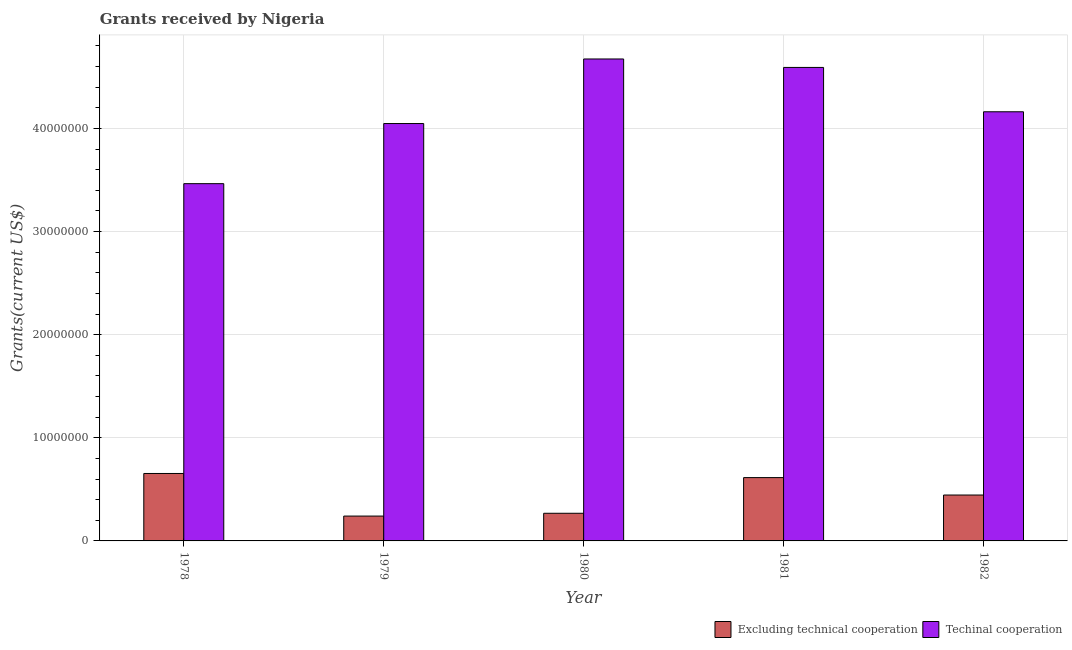Are the number of bars on each tick of the X-axis equal?
Offer a terse response. Yes. How many bars are there on the 3rd tick from the left?
Your answer should be compact. 2. How many bars are there on the 2nd tick from the right?
Your response must be concise. 2. What is the label of the 4th group of bars from the left?
Make the answer very short. 1981. In how many cases, is the number of bars for a given year not equal to the number of legend labels?
Your answer should be compact. 0. What is the amount of grants received(including technical cooperation) in 1978?
Make the answer very short. 3.46e+07. Across all years, what is the maximum amount of grants received(including technical cooperation)?
Make the answer very short. 4.67e+07. Across all years, what is the minimum amount of grants received(excluding technical cooperation)?
Give a very brief answer. 2.41e+06. In which year was the amount of grants received(excluding technical cooperation) maximum?
Provide a succinct answer. 1978. In which year was the amount of grants received(including technical cooperation) minimum?
Make the answer very short. 1978. What is the total amount of grants received(excluding technical cooperation) in the graph?
Provide a succinct answer. 2.22e+07. What is the difference between the amount of grants received(excluding technical cooperation) in 1981 and that in 1982?
Your answer should be compact. 1.69e+06. What is the difference between the amount of grants received(excluding technical cooperation) in 1978 and the amount of grants received(including technical cooperation) in 1981?
Offer a terse response. 4.00e+05. What is the average amount of grants received(excluding technical cooperation) per year?
Offer a very short reply. 4.44e+06. In the year 1981, what is the difference between the amount of grants received(including technical cooperation) and amount of grants received(excluding technical cooperation)?
Your answer should be compact. 0. What is the ratio of the amount of grants received(including technical cooperation) in 1978 to that in 1979?
Your answer should be very brief. 0.86. Is the amount of grants received(including technical cooperation) in 1980 less than that in 1982?
Give a very brief answer. No. Is the difference between the amount of grants received(excluding technical cooperation) in 1978 and 1981 greater than the difference between the amount of grants received(including technical cooperation) in 1978 and 1981?
Offer a very short reply. No. What is the difference between the highest and the second highest amount of grants received(including technical cooperation)?
Offer a very short reply. 8.20e+05. What is the difference between the highest and the lowest amount of grants received(including technical cooperation)?
Offer a very short reply. 1.21e+07. What does the 2nd bar from the left in 1978 represents?
Your answer should be compact. Techinal cooperation. What does the 2nd bar from the right in 1982 represents?
Your answer should be very brief. Excluding technical cooperation. How many years are there in the graph?
Your response must be concise. 5. What is the difference between two consecutive major ticks on the Y-axis?
Provide a short and direct response. 1.00e+07. Does the graph contain any zero values?
Make the answer very short. No. Does the graph contain grids?
Your answer should be very brief. Yes. What is the title of the graph?
Provide a succinct answer. Grants received by Nigeria. Does "Quality of trade" appear as one of the legend labels in the graph?
Offer a terse response. No. What is the label or title of the X-axis?
Keep it short and to the point. Year. What is the label or title of the Y-axis?
Keep it short and to the point. Grants(current US$). What is the Grants(current US$) in Excluding technical cooperation in 1978?
Your response must be concise. 6.54e+06. What is the Grants(current US$) of Techinal cooperation in 1978?
Offer a terse response. 3.46e+07. What is the Grants(current US$) in Excluding technical cooperation in 1979?
Provide a short and direct response. 2.41e+06. What is the Grants(current US$) of Techinal cooperation in 1979?
Provide a succinct answer. 4.05e+07. What is the Grants(current US$) of Excluding technical cooperation in 1980?
Your answer should be compact. 2.68e+06. What is the Grants(current US$) in Techinal cooperation in 1980?
Your answer should be compact. 4.67e+07. What is the Grants(current US$) in Excluding technical cooperation in 1981?
Offer a terse response. 6.14e+06. What is the Grants(current US$) in Techinal cooperation in 1981?
Offer a terse response. 4.59e+07. What is the Grants(current US$) in Excluding technical cooperation in 1982?
Your answer should be very brief. 4.45e+06. What is the Grants(current US$) of Techinal cooperation in 1982?
Offer a very short reply. 4.16e+07. Across all years, what is the maximum Grants(current US$) in Excluding technical cooperation?
Your response must be concise. 6.54e+06. Across all years, what is the maximum Grants(current US$) in Techinal cooperation?
Give a very brief answer. 4.67e+07. Across all years, what is the minimum Grants(current US$) in Excluding technical cooperation?
Provide a short and direct response. 2.41e+06. Across all years, what is the minimum Grants(current US$) of Techinal cooperation?
Provide a short and direct response. 3.46e+07. What is the total Grants(current US$) of Excluding technical cooperation in the graph?
Keep it short and to the point. 2.22e+07. What is the total Grants(current US$) of Techinal cooperation in the graph?
Ensure brevity in your answer.  2.09e+08. What is the difference between the Grants(current US$) of Excluding technical cooperation in 1978 and that in 1979?
Your answer should be very brief. 4.13e+06. What is the difference between the Grants(current US$) of Techinal cooperation in 1978 and that in 1979?
Offer a terse response. -5.83e+06. What is the difference between the Grants(current US$) of Excluding technical cooperation in 1978 and that in 1980?
Make the answer very short. 3.86e+06. What is the difference between the Grants(current US$) of Techinal cooperation in 1978 and that in 1980?
Make the answer very short. -1.21e+07. What is the difference between the Grants(current US$) in Techinal cooperation in 1978 and that in 1981?
Offer a very short reply. -1.13e+07. What is the difference between the Grants(current US$) in Excluding technical cooperation in 1978 and that in 1982?
Provide a short and direct response. 2.09e+06. What is the difference between the Grants(current US$) of Techinal cooperation in 1978 and that in 1982?
Provide a succinct answer. -6.97e+06. What is the difference between the Grants(current US$) in Techinal cooperation in 1979 and that in 1980?
Your response must be concise. -6.26e+06. What is the difference between the Grants(current US$) of Excluding technical cooperation in 1979 and that in 1981?
Ensure brevity in your answer.  -3.73e+06. What is the difference between the Grants(current US$) of Techinal cooperation in 1979 and that in 1981?
Make the answer very short. -5.44e+06. What is the difference between the Grants(current US$) of Excluding technical cooperation in 1979 and that in 1982?
Your response must be concise. -2.04e+06. What is the difference between the Grants(current US$) in Techinal cooperation in 1979 and that in 1982?
Your response must be concise. -1.14e+06. What is the difference between the Grants(current US$) in Excluding technical cooperation in 1980 and that in 1981?
Provide a succinct answer. -3.46e+06. What is the difference between the Grants(current US$) in Techinal cooperation in 1980 and that in 1981?
Offer a very short reply. 8.20e+05. What is the difference between the Grants(current US$) of Excluding technical cooperation in 1980 and that in 1982?
Your answer should be compact. -1.77e+06. What is the difference between the Grants(current US$) of Techinal cooperation in 1980 and that in 1982?
Provide a succinct answer. 5.12e+06. What is the difference between the Grants(current US$) of Excluding technical cooperation in 1981 and that in 1982?
Offer a very short reply. 1.69e+06. What is the difference between the Grants(current US$) of Techinal cooperation in 1981 and that in 1982?
Ensure brevity in your answer.  4.30e+06. What is the difference between the Grants(current US$) of Excluding technical cooperation in 1978 and the Grants(current US$) of Techinal cooperation in 1979?
Provide a short and direct response. -3.39e+07. What is the difference between the Grants(current US$) in Excluding technical cooperation in 1978 and the Grants(current US$) in Techinal cooperation in 1980?
Provide a succinct answer. -4.02e+07. What is the difference between the Grants(current US$) in Excluding technical cooperation in 1978 and the Grants(current US$) in Techinal cooperation in 1981?
Provide a succinct answer. -3.94e+07. What is the difference between the Grants(current US$) of Excluding technical cooperation in 1978 and the Grants(current US$) of Techinal cooperation in 1982?
Provide a short and direct response. -3.51e+07. What is the difference between the Grants(current US$) in Excluding technical cooperation in 1979 and the Grants(current US$) in Techinal cooperation in 1980?
Offer a very short reply. -4.43e+07. What is the difference between the Grants(current US$) in Excluding technical cooperation in 1979 and the Grants(current US$) in Techinal cooperation in 1981?
Your answer should be compact. -4.35e+07. What is the difference between the Grants(current US$) in Excluding technical cooperation in 1979 and the Grants(current US$) in Techinal cooperation in 1982?
Your response must be concise. -3.92e+07. What is the difference between the Grants(current US$) of Excluding technical cooperation in 1980 and the Grants(current US$) of Techinal cooperation in 1981?
Make the answer very short. -4.32e+07. What is the difference between the Grants(current US$) in Excluding technical cooperation in 1980 and the Grants(current US$) in Techinal cooperation in 1982?
Your answer should be very brief. -3.89e+07. What is the difference between the Grants(current US$) of Excluding technical cooperation in 1981 and the Grants(current US$) of Techinal cooperation in 1982?
Ensure brevity in your answer.  -3.55e+07. What is the average Grants(current US$) in Excluding technical cooperation per year?
Make the answer very short. 4.44e+06. What is the average Grants(current US$) of Techinal cooperation per year?
Make the answer very short. 4.19e+07. In the year 1978, what is the difference between the Grants(current US$) of Excluding technical cooperation and Grants(current US$) of Techinal cooperation?
Offer a terse response. -2.81e+07. In the year 1979, what is the difference between the Grants(current US$) in Excluding technical cooperation and Grants(current US$) in Techinal cooperation?
Make the answer very short. -3.81e+07. In the year 1980, what is the difference between the Grants(current US$) of Excluding technical cooperation and Grants(current US$) of Techinal cooperation?
Your answer should be compact. -4.40e+07. In the year 1981, what is the difference between the Grants(current US$) of Excluding technical cooperation and Grants(current US$) of Techinal cooperation?
Offer a terse response. -3.98e+07. In the year 1982, what is the difference between the Grants(current US$) of Excluding technical cooperation and Grants(current US$) of Techinal cooperation?
Provide a short and direct response. -3.72e+07. What is the ratio of the Grants(current US$) of Excluding technical cooperation in 1978 to that in 1979?
Ensure brevity in your answer.  2.71. What is the ratio of the Grants(current US$) in Techinal cooperation in 1978 to that in 1979?
Make the answer very short. 0.86. What is the ratio of the Grants(current US$) in Excluding technical cooperation in 1978 to that in 1980?
Offer a very short reply. 2.44. What is the ratio of the Grants(current US$) in Techinal cooperation in 1978 to that in 1980?
Ensure brevity in your answer.  0.74. What is the ratio of the Grants(current US$) of Excluding technical cooperation in 1978 to that in 1981?
Keep it short and to the point. 1.07. What is the ratio of the Grants(current US$) of Techinal cooperation in 1978 to that in 1981?
Provide a succinct answer. 0.75. What is the ratio of the Grants(current US$) in Excluding technical cooperation in 1978 to that in 1982?
Make the answer very short. 1.47. What is the ratio of the Grants(current US$) of Techinal cooperation in 1978 to that in 1982?
Make the answer very short. 0.83. What is the ratio of the Grants(current US$) of Excluding technical cooperation in 1979 to that in 1980?
Keep it short and to the point. 0.9. What is the ratio of the Grants(current US$) in Techinal cooperation in 1979 to that in 1980?
Offer a terse response. 0.87. What is the ratio of the Grants(current US$) of Excluding technical cooperation in 1979 to that in 1981?
Provide a succinct answer. 0.39. What is the ratio of the Grants(current US$) in Techinal cooperation in 1979 to that in 1981?
Provide a succinct answer. 0.88. What is the ratio of the Grants(current US$) in Excluding technical cooperation in 1979 to that in 1982?
Ensure brevity in your answer.  0.54. What is the ratio of the Grants(current US$) in Techinal cooperation in 1979 to that in 1982?
Give a very brief answer. 0.97. What is the ratio of the Grants(current US$) of Excluding technical cooperation in 1980 to that in 1981?
Your answer should be compact. 0.44. What is the ratio of the Grants(current US$) of Techinal cooperation in 1980 to that in 1981?
Keep it short and to the point. 1.02. What is the ratio of the Grants(current US$) in Excluding technical cooperation in 1980 to that in 1982?
Your response must be concise. 0.6. What is the ratio of the Grants(current US$) in Techinal cooperation in 1980 to that in 1982?
Keep it short and to the point. 1.12. What is the ratio of the Grants(current US$) of Excluding technical cooperation in 1981 to that in 1982?
Give a very brief answer. 1.38. What is the ratio of the Grants(current US$) of Techinal cooperation in 1981 to that in 1982?
Ensure brevity in your answer.  1.1. What is the difference between the highest and the second highest Grants(current US$) of Techinal cooperation?
Offer a very short reply. 8.20e+05. What is the difference between the highest and the lowest Grants(current US$) of Excluding technical cooperation?
Offer a very short reply. 4.13e+06. What is the difference between the highest and the lowest Grants(current US$) of Techinal cooperation?
Make the answer very short. 1.21e+07. 